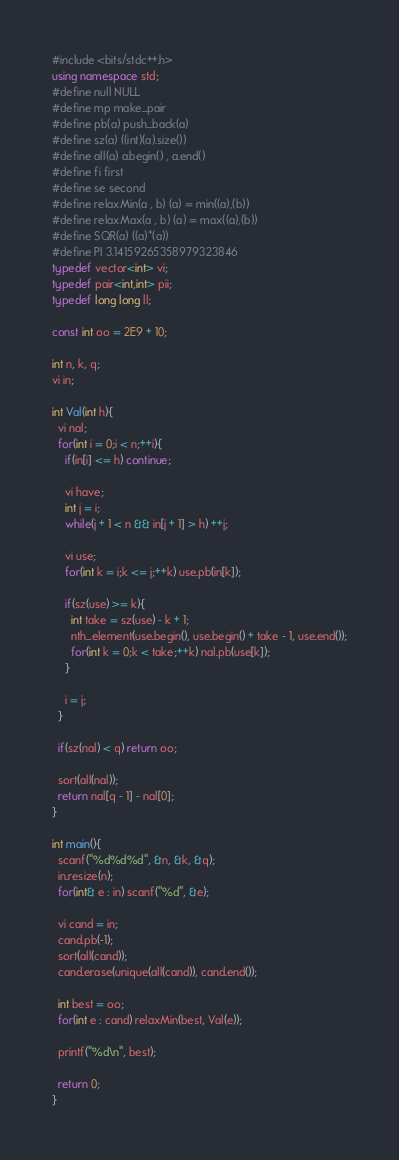<code> <loc_0><loc_0><loc_500><loc_500><_C++_>#include <bits/stdc++.h>
using namespace std;
#define null NULL
#define mp make_pair
#define pb(a) push_back(a)
#define sz(a) ((int)(a).size())
#define all(a) a.begin() , a.end()
#define fi first
#define se second
#define relaxMin(a , b) (a) = min((a),(b))
#define relaxMax(a , b) (a) = max((a),(b))
#define SQR(a) ((a)*(a))
#define PI 3.14159265358979323846
typedef vector<int> vi;
typedef pair<int,int> pii;
typedef long long ll;

const int oo = 2E9 + 10;

int n, k, q;
vi in;

int Val(int h){
  vi nal;
  for(int i = 0;i < n;++i){
    if(in[i] <= h) continue;

    vi have;
    int j = i;
    while(j + 1 < n && in[j + 1] > h) ++j;

    vi use;
    for(int k = i;k <= j;++k) use.pb(in[k]);

    if(sz(use) >= k){
      int take = sz(use) - k + 1;
      nth_element(use.begin(), use.begin() + take - 1, use.end());
      for(int k = 0;k < take;++k) nal.pb(use[k]);
    }

    i = j;
  }

  if(sz(nal) < q) return oo;

  sort(all(nal));
  return nal[q - 1] - nal[0];
}

int main(){
  scanf("%d%d%d", &n, &k, &q);
  in.resize(n);
  for(int& e : in) scanf("%d", &e);

  vi cand = in;
  cand.pb(-1);
  sort(all(cand));
  cand.erase(unique(all(cand)), cand.end());

  int best = oo;
  for(int e : cand) relaxMin(best, Val(e));

  printf("%d\n", best);

  return 0;
}
</code> 